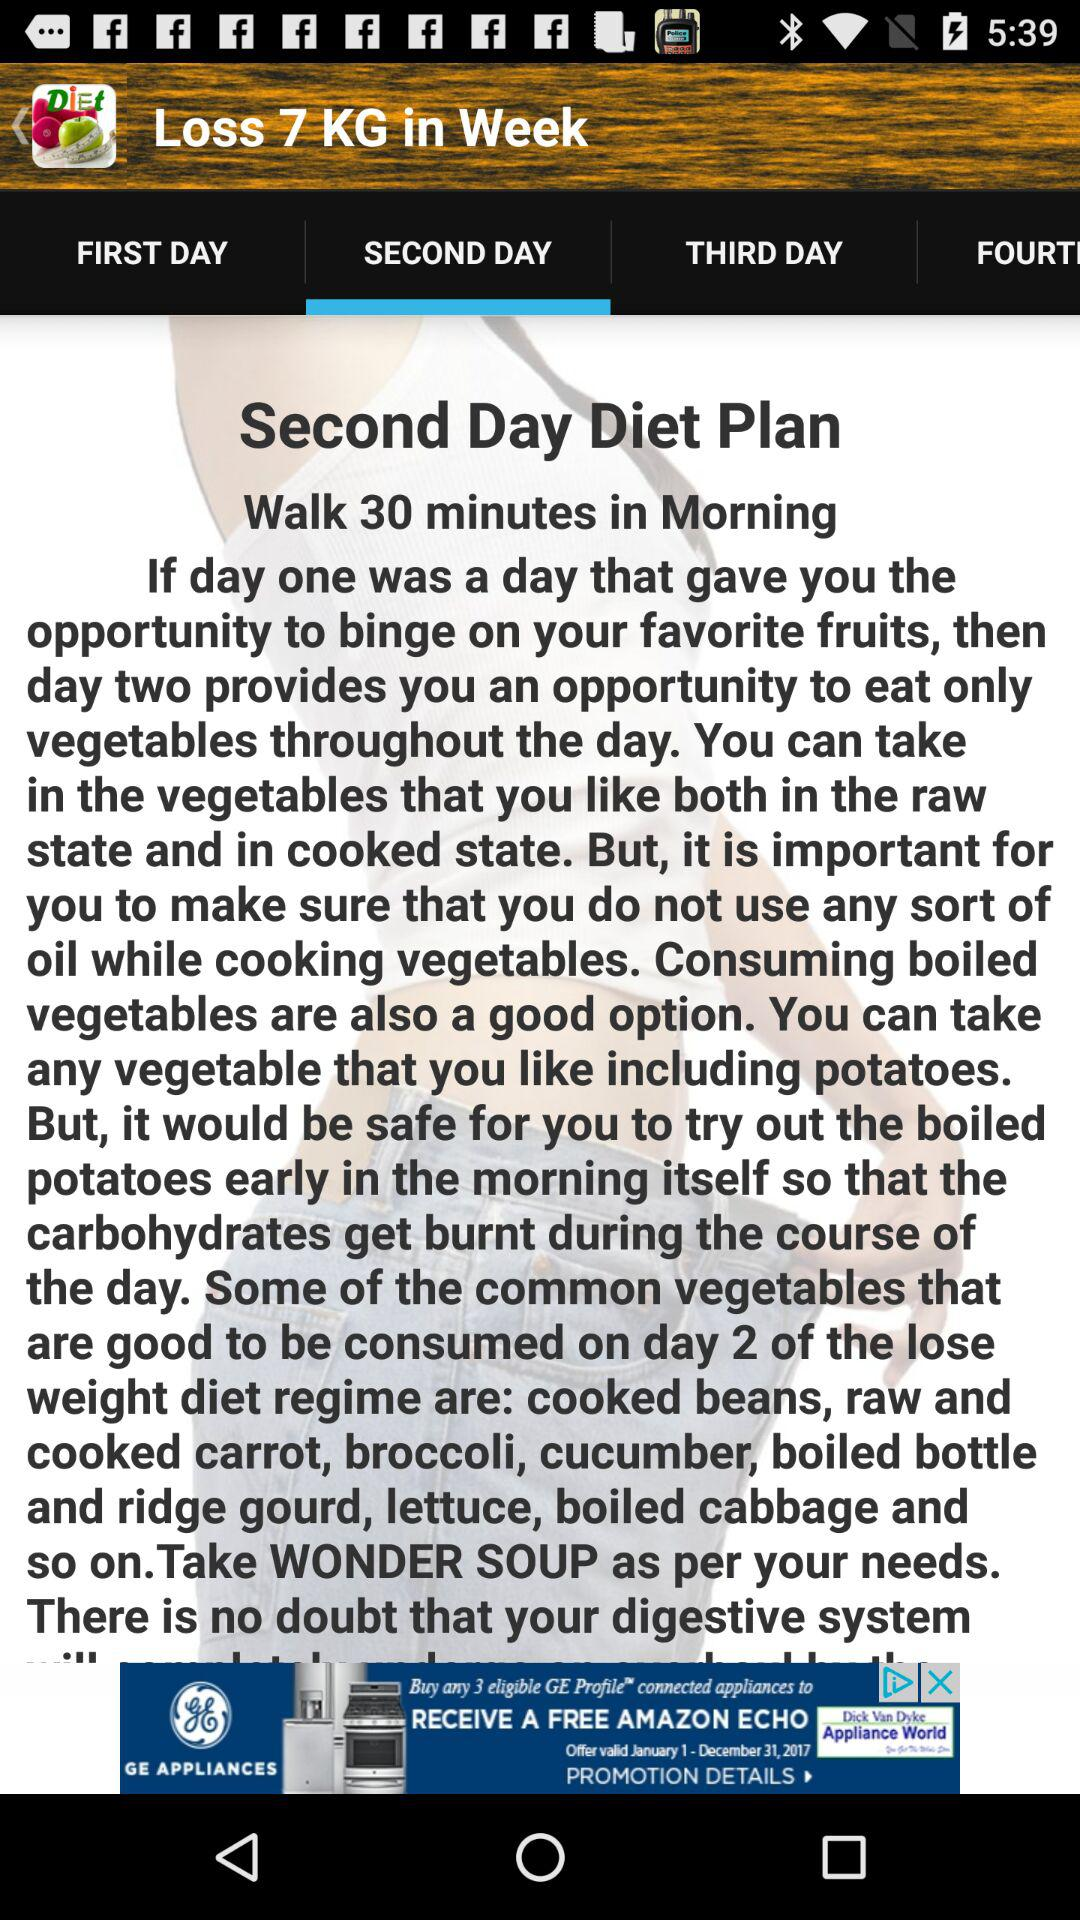How much weight can be lost in a week? In a week, 7 kg of weight can be lost. 